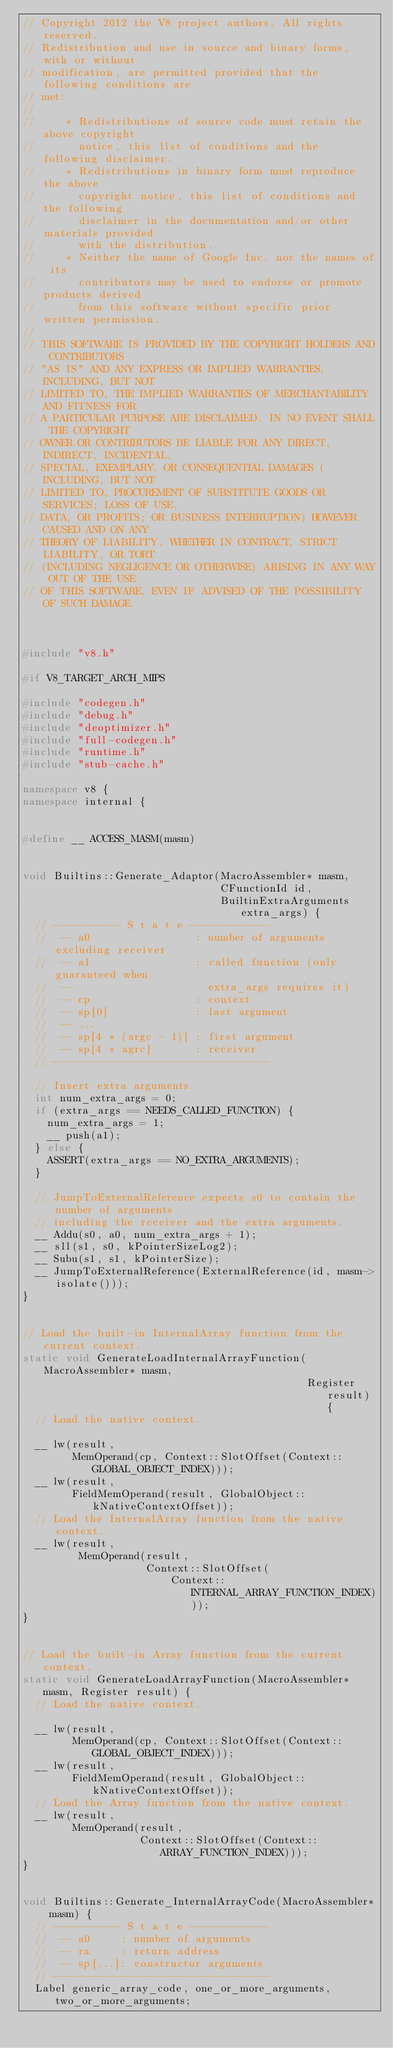Convert code to text. <code><loc_0><loc_0><loc_500><loc_500><_C++_>// Copyright 2012 the V8 project authors. All rights reserved.
// Redistribution and use in source and binary forms, with or without
// modification, are permitted provided that the following conditions are
// met:
//
//     * Redistributions of source code must retain the above copyright
//       notice, this list of conditions and the following disclaimer.
//     * Redistributions in binary form must reproduce the above
//       copyright notice, this list of conditions and the following
//       disclaimer in the documentation and/or other materials provided
//       with the distribution.
//     * Neither the name of Google Inc. nor the names of its
//       contributors may be used to endorse or promote products derived
//       from this software without specific prior written permission.
//
// THIS SOFTWARE IS PROVIDED BY THE COPYRIGHT HOLDERS AND CONTRIBUTORS
// "AS IS" AND ANY EXPRESS OR IMPLIED WARRANTIES, INCLUDING, BUT NOT
// LIMITED TO, THE IMPLIED WARRANTIES OF MERCHANTABILITY AND FITNESS FOR
// A PARTICULAR PURPOSE ARE DISCLAIMED. IN NO EVENT SHALL THE COPYRIGHT
// OWNER OR CONTRIBUTORS BE LIABLE FOR ANY DIRECT, INDIRECT, INCIDENTAL,
// SPECIAL, EXEMPLARY, OR CONSEQUENTIAL DAMAGES (INCLUDING, BUT NOT
// LIMITED TO, PROCUREMENT OF SUBSTITUTE GOODS OR SERVICES; LOSS OF USE,
// DATA, OR PROFITS; OR BUSINESS INTERRUPTION) HOWEVER CAUSED AND ON ANY
// THEORY OF LIABILITY, WHETHER IN CONTRACT, STRICT LIABILITY, OR TORT
// (INCLUDING NEGLIGENCE OR OTHERWISE) ARISING IN ANY WAY OUT OF THE USE
// OF THIS SOFTWARE, EVEN IF ADVISED OF THE POSSIBILITY OF SUCH DAMAGE.



#include "v8.h"

#if V8_TARGET_ARCH_MIPS

#include "codegen.h"
#include "debug.h"
#include "deoptimizer.h"
#include "full-codegen.h"
#include "runtime.h"
#include "stub-cache.h"

namespace v8 {
namespace internal {


#define __ ACCESS_MASM(masm)


void Builtins::Generate_Adaptor(MacroAssembler* masm,
                                CFunctionId id,
                                BuiltinExtraArguments extra_args) {
  // ----------- S t a t e -------------
  //  -- a0                 : number of arguments excluding receiver
  //  -- a1                 : called function (only guaranteed when
  //  --                      extra_args requires it)
  //  -- cp                 : context
  //  -- sp[0]              : last argument
  //  -- ...
  //  -- sp[4 * (argc - 1)] : first argument
  //  -- sp[4 * agrc]       : receiver
  // -----------------------------------

  // Insert extra arguments.
  int num_extra_args = 0;
  if (extra_args == NEEDS_CALLED_FUNCTION) {
    num_extra_args = 1;
    __ push(a1);
  } else {
    ASSERT(extra_args == NO_EXTRA_ARGUMENTS);
  }

  // JumpToExternalReference expects s0 to contain the number of arguments
  // including the receiver and the extra arguments.
  __ Addu(s0, a0, num_extra_args + 1);
  __ sll(s1, s0, kPointerSizeLog2);
  __ Subu(s1, s1, kPointerSize);
  __ JumpToExternalReference(ExternalReference(id, masm->isolate()));
}


// Load the built-in InternalArray function from the current context.
static void GenerateLoadInternalArrayFunction(MacroAssembler* masm,
                                              Register result) {
  // Load the native context.

  __ lw(result,
        MemOperand(cp, Context::SlotOffset(Context::GLOBAL_OBJECT_INDEX)));
  __ lw(result,
        FieldMemOperand(result, GlobalObject::kNativeContextOffset));
  // Load the InternalArray function from the native context.
  __ lw(result,
         MemOperand(result,
                    Context::SlotOffset(
                        Context::INTERNAL_ARRAY_FUNCTION_INDEX)));
}


// Load the built-in Array function from the current context.
static void GenerateLoadArrayFunction(MacroAssembler* masm, Register result) {
  // Load the native context.

  __ lw(result,
        MemOperand(cp, Context::SlotOffset(Context::GLOBAL_OBJECT_INDEX)));
  __ lw(result,
        FieldMemOperand(result, GlobalObject::kNativeContextOffset));
  // Load the Array function from the native context.
  __ lw(result,
        MemOperand(result,
                   Context::SlotOffset(Context::ARRAY_FUNCTION_INDEX)));
}


void Builtins::Generate_InternalArrayCode(MacroAssembler* masm) {
  // ----------- S t a t e -------------
  //  -- a0     : number of arguments
  //  -- ra     : return address
  //  -- sp[...]: constructor arguments
  // -----------------------------------
  Label generic_array_code, one_or_more_arguments, two_or_more_arguments;
</code> 